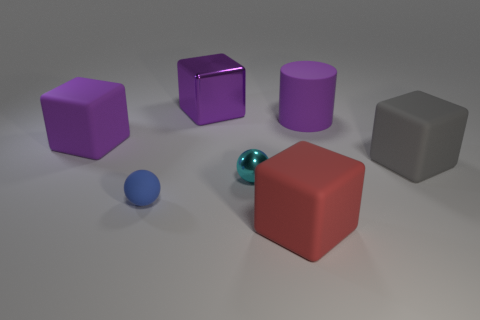Subtract all rubber cubes. How many cubes are left? 1 Subtract all blocks. How many objects are left? 3 Subtract all red cubes. How many cubes are left? 3 Add 4 large purple cylinders. How many large purple cylinders are left? 5 Add 4 blue matte things. How many blue matte things exist? 5 Add 1 tiny matte objects. How many objects exist? 8 Subtract 1 purple cylinders. How many objects are left? 6 Subtract 1 cubes. How many cubes are left? 3 Subtract all brown spheres. Subtract all red cubes. How many spheres are left? 2 Subtract all cyan spheres. How many blue cubes are left? 0 